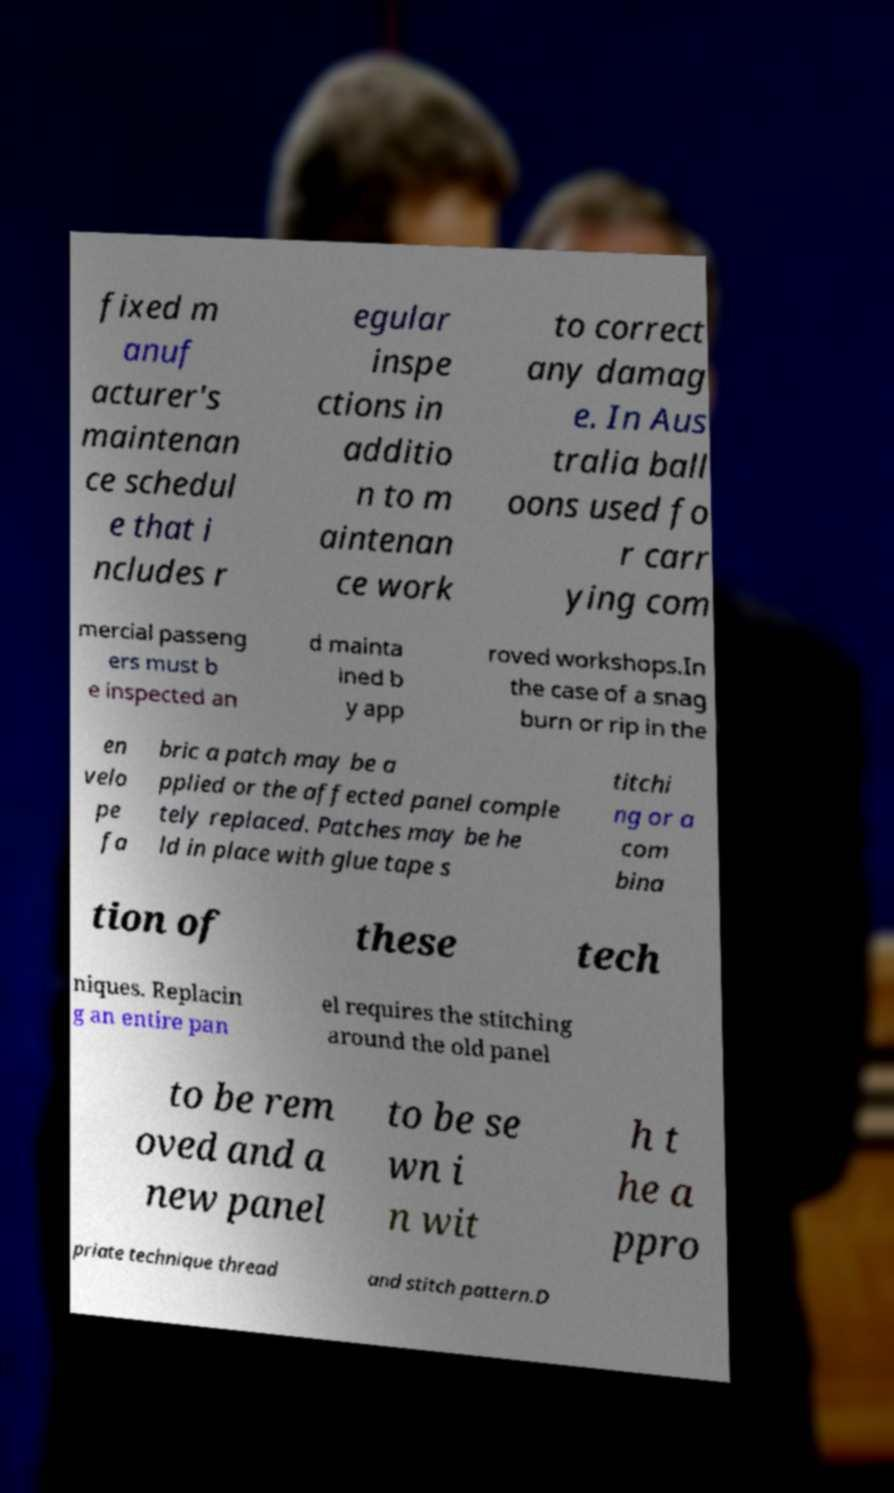Can you accurately transcribe the text from the provided image for me? fixed m anuf acturer's maintenan ce schedul e that i ncludes r egular inspe ctions in additio n to m aintenan ce work to correct any damag e. In Aus tralia ball oons used fo r carr ying com mercial passeng ers must b e inspected an d mainta ined b y app roved workshops.In the case of a snag burn or rip in the en velo pe fa bric a patch may be a pplied or the affected panel comple tely replaced. Patches may be he ld in place with glue tape s titchi ng or a com bina tion of these tech niques. Replacin g an entire pan el requires the stitching around the old panel to be rem oved and a new panel to be se wn i n wit h t he a ppro priate technique thread and stitch pattern.D 